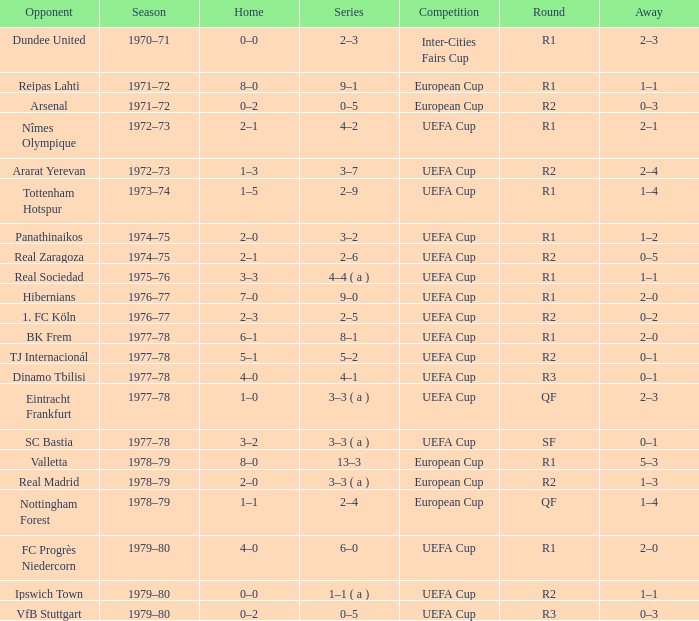Which Round has a Competition of uefa cup, and a Series of 5–2? R2. 